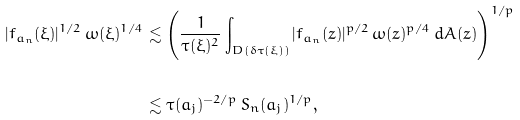<formula> <loc_0><loc_0><loc_500><loc_500>| f _ { a _ { n } } ( \xi ) | ^ { 1 / 2 } \, \omega ( \xi ) ^ { 1 / 4 } & \lesssim \left ( \frac { 1 } { \tau ( \xi ) ^ { 2 } } \int _ { D ( \delta \tau ( \xi ) ) } | f _ { a _ { n } } ( z ) | ^ { p / 2 } \, \omega ( z ) ^ { p / 4 } \, d A ( z ) \right ) ^ { 1 / p } \\ \\ & \lesssim \tau ( a _ { j } ) ^ { - 2 / p } \, S _ { n } ( a _ { j } ) ^ { 1 / p } ,</formula> 